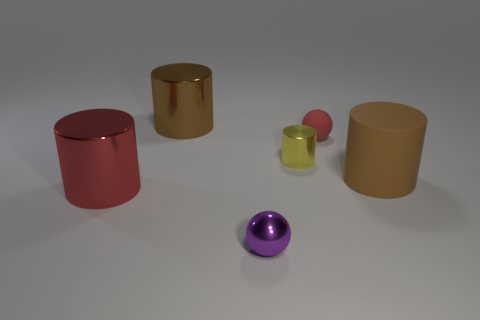Is the material of the tiny red object the same as the big brown cylinder that is to the right of the tiny rubber thing?
Offer a terse response. Yes. Is the number of big red metal objects in front of the tiny cylinder greater than the number of things?
Offer a very short reply. No. There is a big matte cylinder; is it the same color as the tiny shiny thing on the right side of the purple metal sphere?
Ensure brevity in your answer.  No. Are there the same number of brown things to the right of the tiny metallic ball and red things that are on the left side of the yellow shiny cylinder?
Ensure brevity in your answer.  Yes. There is a brown cylinder on the left side of the large rubber thing; what is it made of?
Make the answer very short. Metal. How many objects are yellow metallic cylinders left of the tiny red thing or big metallic cylinders?
Offer a terse response. 3. How many other objects are the same shape as the tiny red matte object?
Make the answer very short. 1. Do the matte object left of the big brown rubber object and the big red shiny thing have the same shape?
Keep it short and to the point. No. Are there any large red cylinders to the right of the brown metal cylinder?
Give a very brief answer. No. What number of large objects are either matte spheres or cyan blocks?
Keep it short and to the point. 0. 